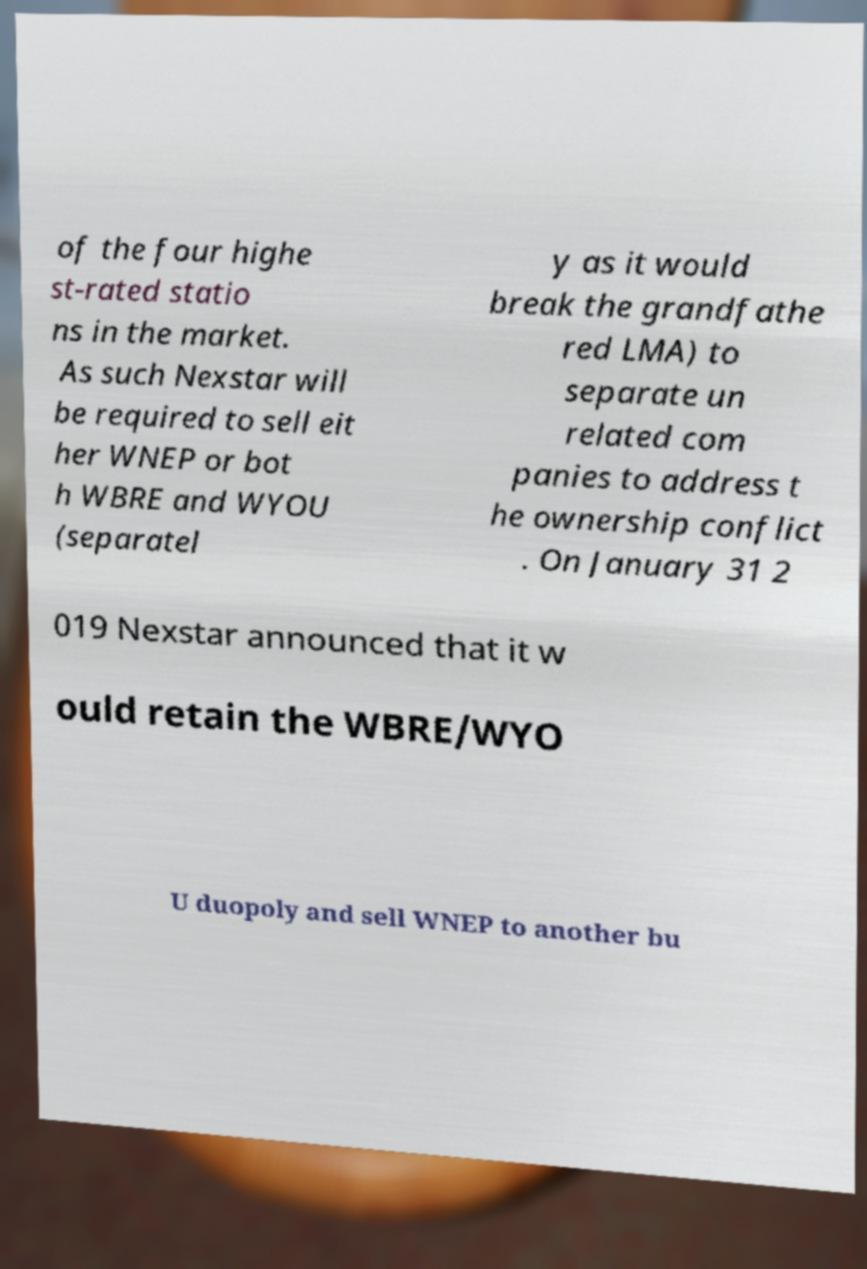Please read and relay the text visible in this image. What does it say? of the four highe st-rated statio ns in the market. As such Nexstar will be required to sell eit her WNEP or bot h WBRE and WYOU (separatel y as it would break the grandfathe red LMA) to separate un related com panies to address t he ownership conflict . On January 31 2 019 Nexstar announced that it w ould retain the WBRE/WYO U duopoly and sell WNEP to another bu 